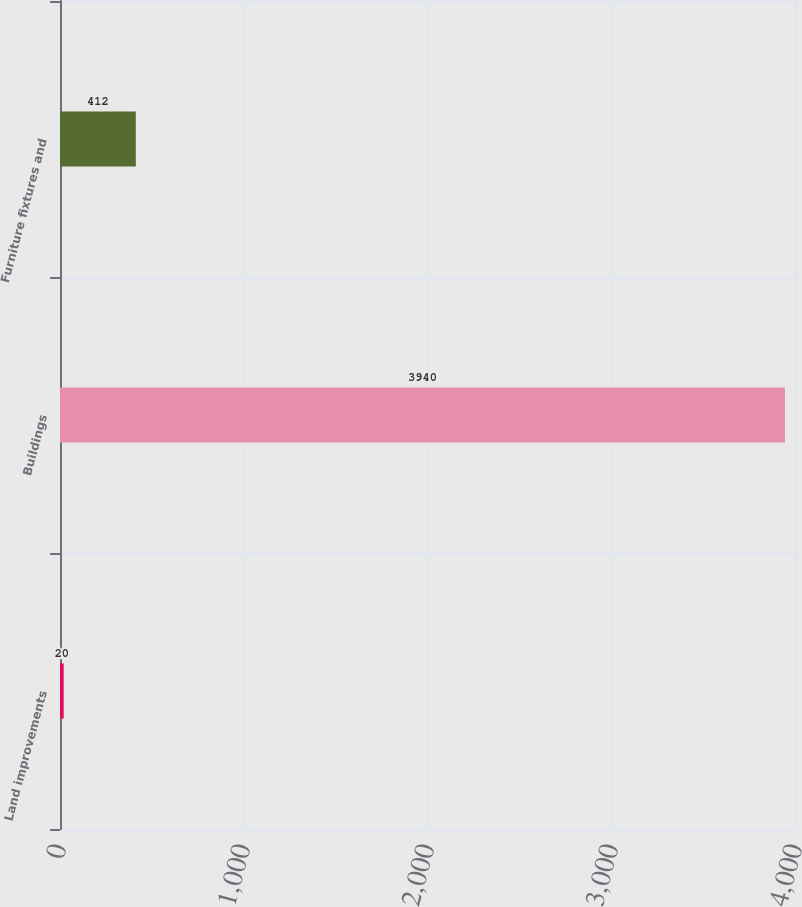<chart> <loc_0><loc_0><loc_500><loc_500><bar_chart><fcel>Land improvements<fcel>Buildings<fcel>Furniture fixtures and<nl><fcel>20<fcel>3940<fcel>412<nl></chart> 